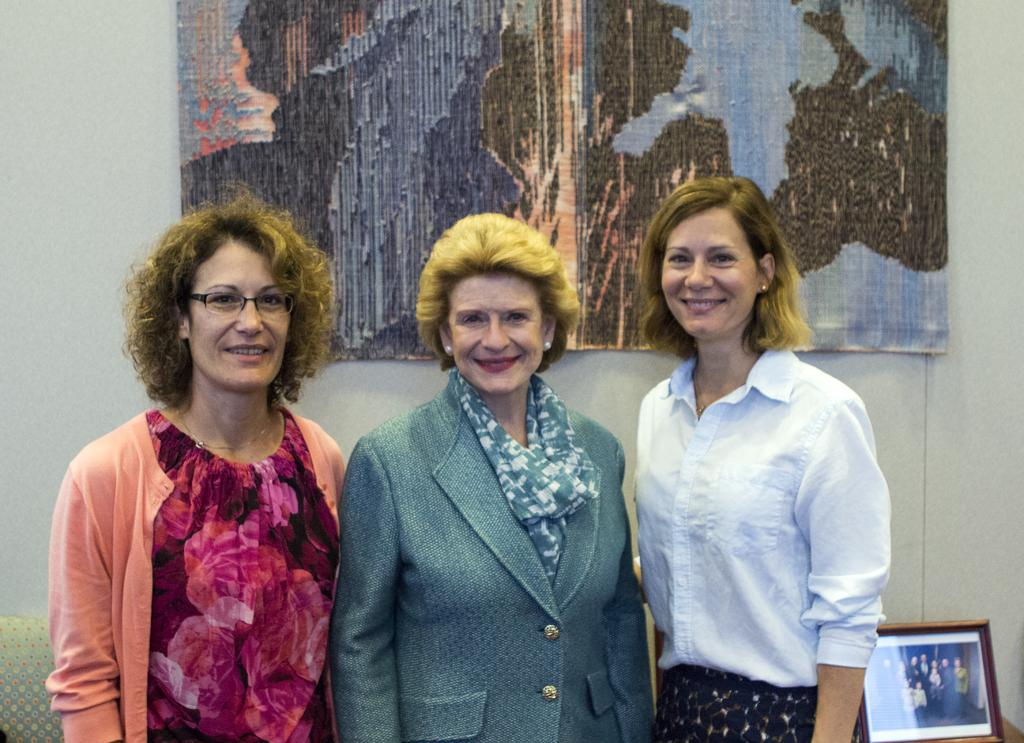How many men are present in the image? There are three men in the image. Where are the men located in the image? The men are in the middle of the image. What else can be seen in the image besides the men? There is a photo frame in the image. On which side of the image is the photo frame located? The photo frame is on the right-hand side of the image. What type of system does the rat use to communicate with the men in the image? There is no rat present in the image, so it is not possible to determine what type of system it might use to communicate with the men. 